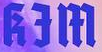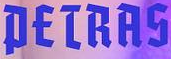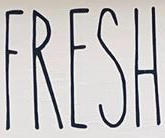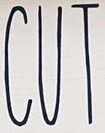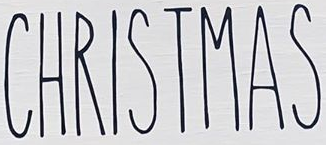Transcribe the words shown in these images in order, separated by a semicolon. kƎm; PETRAS; FRESH; CUT; CHRISTMAS 